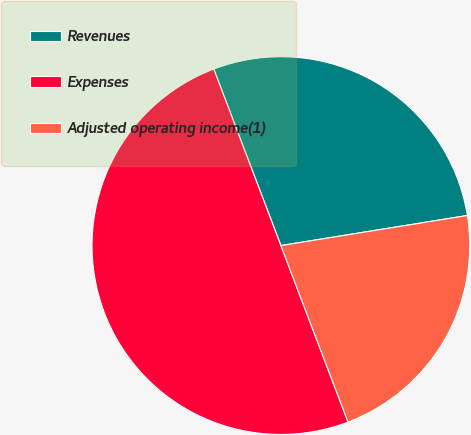<chart> <loc_0><loc_0><loc_500><loc_500><pie_chart><fcel>Revenues<fcel>Expenses<fcel>Adjusted operating income(1)<nl><fcel>28.24%<fcel>50.0%<fcel>21.76%<nl></chart> 